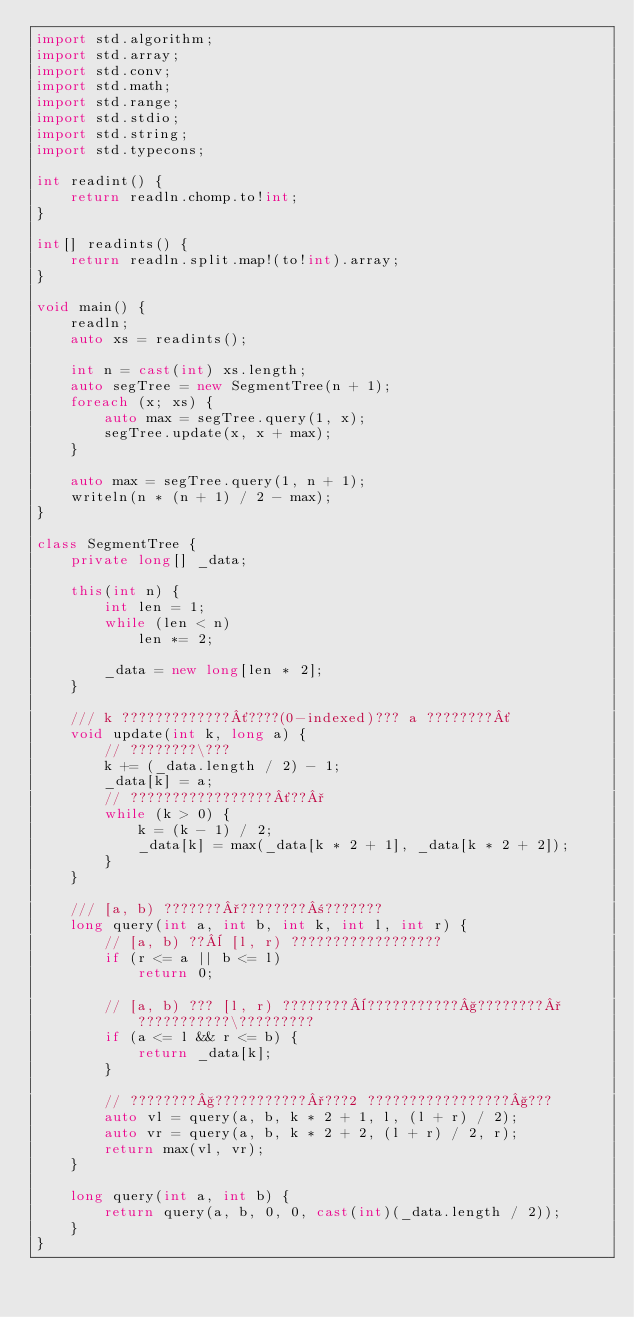<code> <loc_0><loc_0><loc_500><loc_500><_D_>import std.algorithm;
import std.array;
import std.conv;
import std.math;
import std.range;
import std.stdio;
import std.string;
import std.typecons;

int readint() {
    return readln.chomp.to!int;
}

int[] readints() {
    return readln.split.map!(to!int).array;
}

void main() {
    readln;
    auto xs = readints();

    int n = cast(int) xs.length;
    auto segTree = new SegmentTree(n + 1);
    foreach (x; xs) {
        auto max = segTree.query(1, x);
        segTree.update(x, x + max);
    }

    auto max = segTree.query(1, n + 1);
    writeln(n * (n + 1) / 2 - max);
}

class SegmentTree {
    private long[] _data;

    this(int n) {
        int len = 1;
        while (len < n)
            len *= 2;

        _data = new long[len * 2];
    }

    /// k ?????????????´????(0-indexed)??? a ????????´
    void update(int k, long a) {
        // ????????\???
        k += (_data.length / 2) - 1;
        _data[k] = a;
        // ?????????????????´??°
        while (k > 0) {
            k = (k - 1) / 2;
            _data[k] = max(_data[k * 2 + 1], _data[k * 2 + 2]);
        }
    }

    /// [a, b) ???????°????????±???????
    long query(int a, int b, int k, int l, int r) {
        // [a, b) ??¨ [l, r) ??????????????????
        if (r <= a || b <= l)
            return 0;

        // [a, b) ??? [l, r) ????????¨???????????§????????°???????????\?????????
        if (a <= l && r <= b) {
            return _data[k];
        }

        // ????????§???????????°???2 ?????????????????§???
        auto vl = query(a, b, k * 2 + 1, l, (l + r) / 2);
        auto vr = query(a, b, k * 2 + 2, (l + r) / 2, r);
        return max(vl, vr);
    }

    long query(int a, int b) {
        return query(a, b, 0, 0, cast(int)(_data.length / 2));
    }
}</code> 